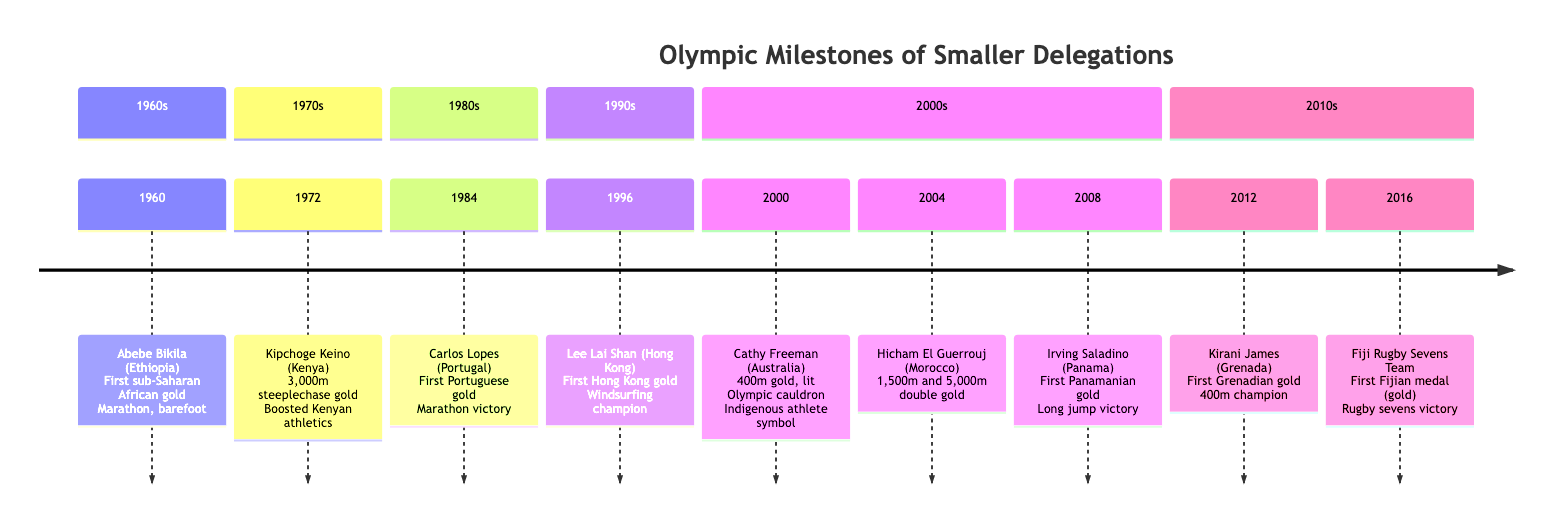What year did Abebe Bikila achieve his Olympic victory? The diagram indicates that Abebe Bikila from Ethiopia won the marathon in the year 1960. To find this, one can look at the earliest element in the timeline which is labeled with his name and the associated year.
Answer: 1960 Which country did Kipchoge Keino represent when he won gold in 1972? Referring to the event listed for the year 1972, it specifies that Kipchoge Keino from Kenya won the 3,000-meter steeplechase. The question is answered by identifying the country associated with Keino’s achievement on the timeline.
Answer: Kenya How many gold medals did Hicham El Guerrouj win at the 2004 Olympics? The entry for the year 2004 indicates that Hicham El Guerrouj from Morocco won both the 1,500 meters and 5,000 meters, thus totaling two gold medals. Thus, counting the events he won gold in provides the answer.
Answer: 2 Which milestone is linked to Fiji at the 2016 Olympics? The timeline entry for 2016 shows that Fiji's rugby sevens team won gold at the Rio de Janeiro Olympics. This can be deduced by examining the specific section detailing Fiji’s achievement.
Answer: First Fijian medal (gold) What event marked Carlos Lopes’ gold medal win in 1984? The event corresponding to the year 1984 states that Carlos Lopes from Portugal won the marathon. This is deduced by looking for the event specifically mentioned in the key milestones of the timeline related to Lopes.
Answer: Marathon victory Which athlete lit the Olympic cauldron in 2000? The timeline specifies in the year 2000 that Cathy Freeman from Australia lit the Olympic cauldron. This can be directly referenced under the 2000 entry in the timeline, which includes that detail as a significant part of her achievement.
Answer: Cathy Freeman What was unique about Lee Lai Shan’s achievement in 1996? The timeline entry for 1996 describes that Lee Lai Shan from Hong Kong won the gold medal in windsurfing, marking Hong Kong’s first-ever Olympic gold medal. This combination of facts indicates the uniqueness of her achievement as the first for her delegation.
Answer: First Hong Kong gold Which country won its first Olympic gold medal in 2008? The event for the year 2008 shows that Irving Saladino from Panama won gold in the long jump, signifying Panama’s first gold medal at the Olympics. This can be recognized by scanning entries for the year and associating it with the term "first."
Answer: Panama 